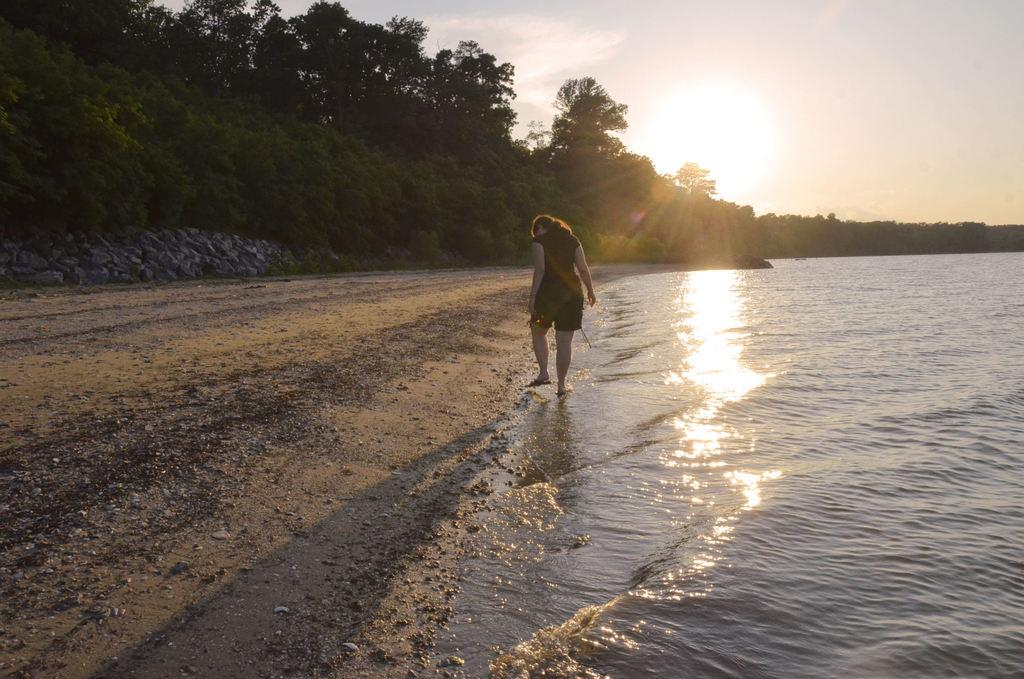What type of vegetation can be seen in the image? There are trees in the image. What natural element is visible in the image besides the trees? There is water visible in the image. What is the woman in the image doing? The woman is walking in the image. How would you describe the sky in the image? The sky is cloudy, but sunlight is also visible. What type of rice can be seen growing in the image? There is no rice present in the image; it features trees, water, a woman walking, and a cloudy sky with sunlight. How does the zephyr affect the woman's walk in the image? There is no mention of a zephyr or any wind in the image, so it cannot be determined how it would affect the woman's walk. 